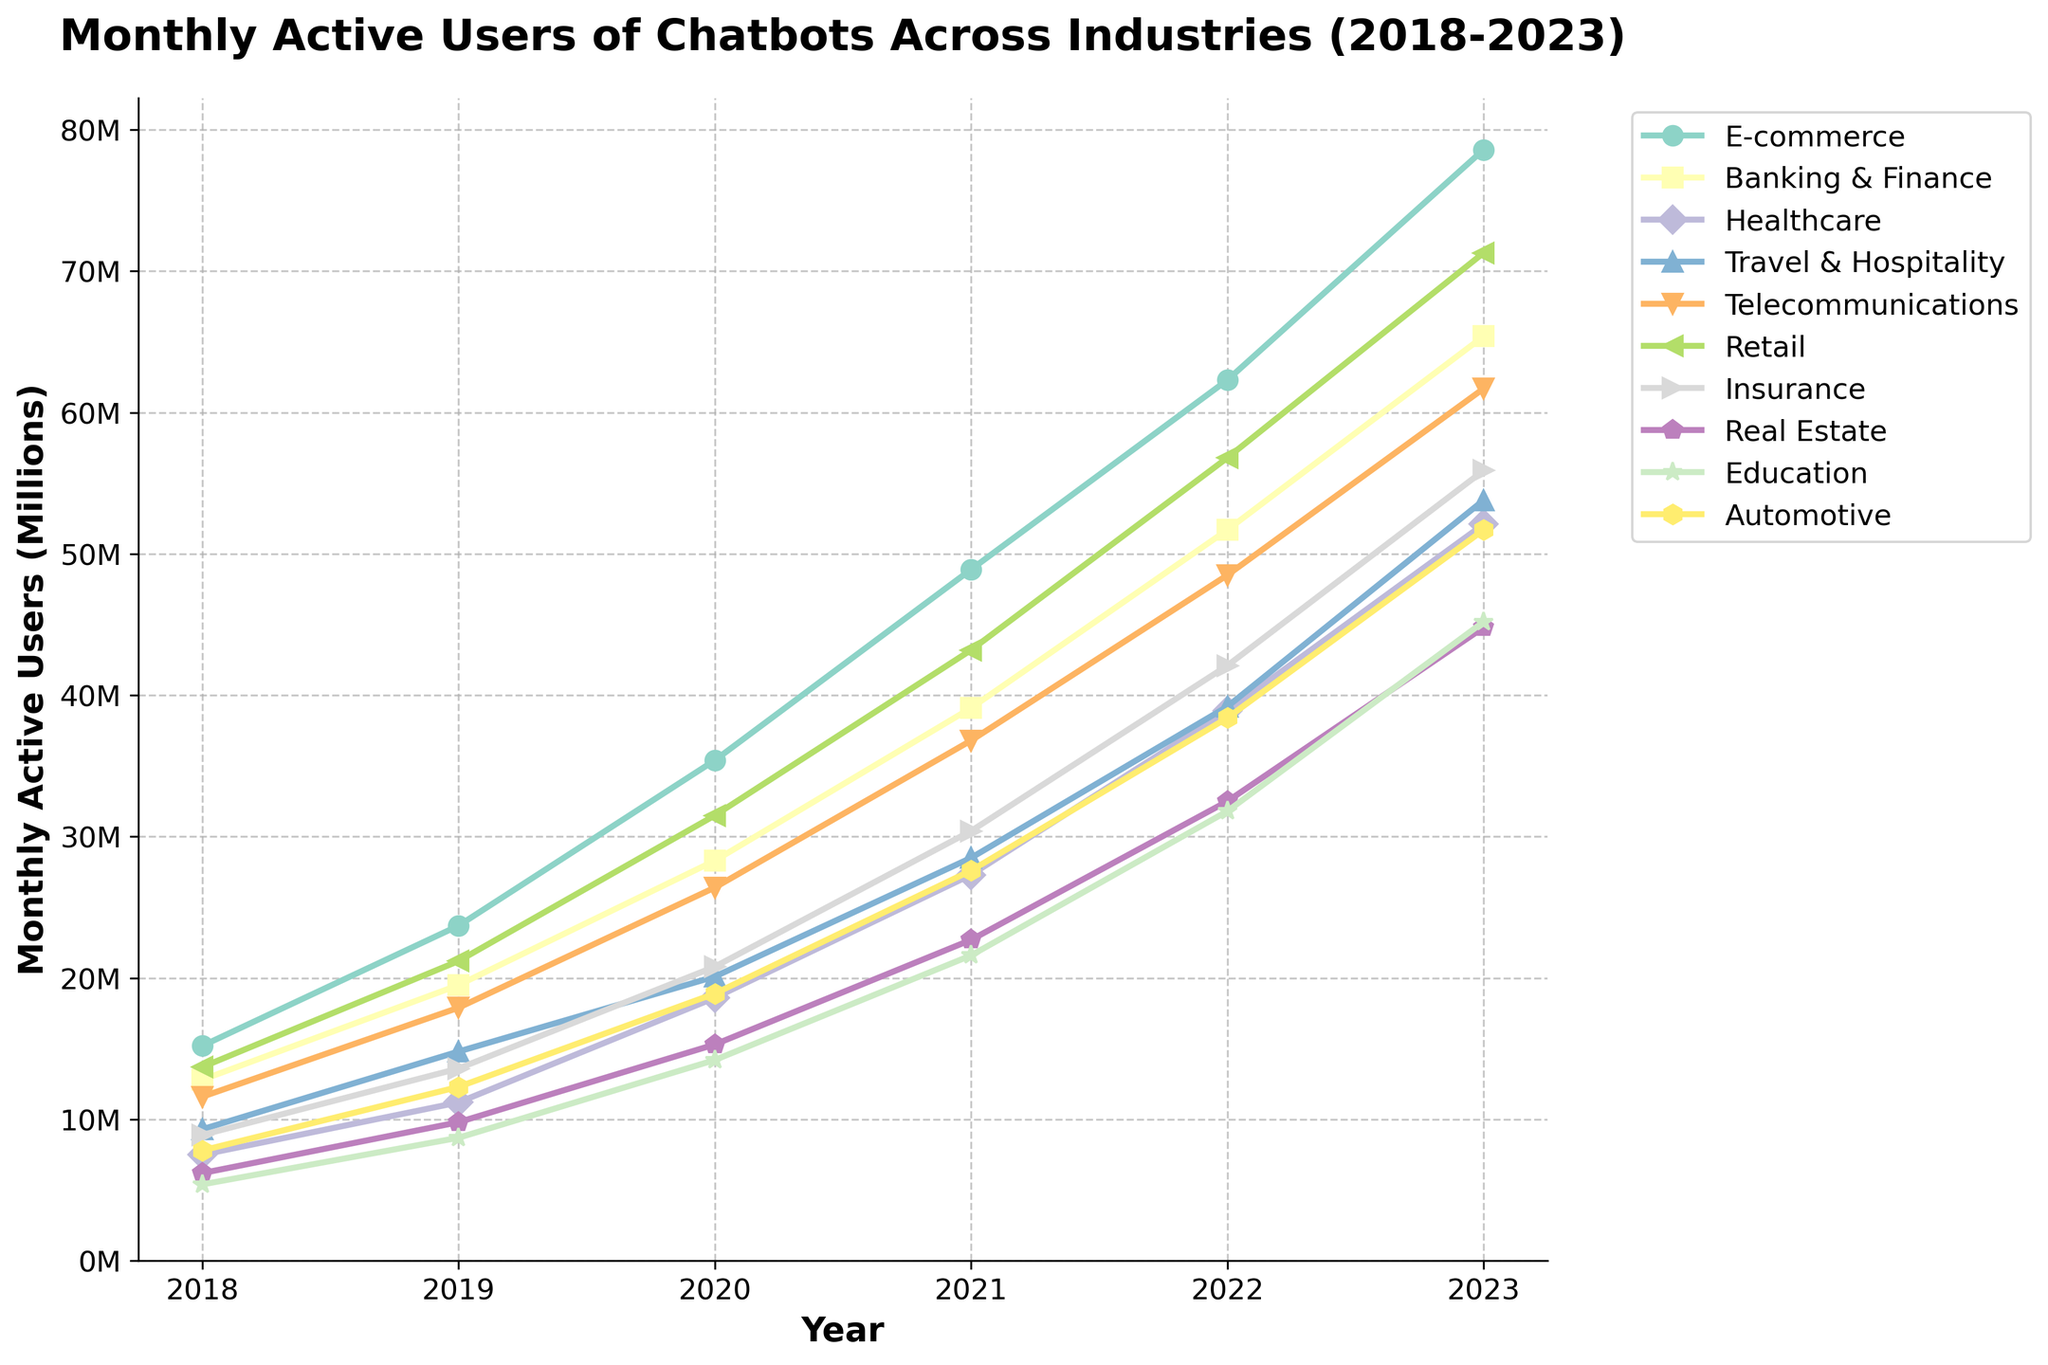what industry has the highest number of monthly active users in 2023? The figure shows multiple industries with their corresponding monthly active users for each year. In 2023, the line for E-commerce reaches the highest point compared to all other industries around 78.6 million users.
Answer: E-commerce Which industry saw the greatest increase in monthly active users between 2018 and 2023? To determine this, find the difference in monthly active users for each industry between 2018 and 2023 and identify the largest difference. E-commerce increased from 15.2 million in 2018 to 78.6 million in 2023, which is a difference of 63.4 million, the highest among all industries.
Answer: E-commerce How did the Banking & Finance sector's monthly active users in 2019 compare to 2020? Locate the monthly active user values for Banking & Finance in 2019 and 2020 in the figure. In 2019, the value is 19.5 million and in 2020, it is 28.3 million. Subtracting the 2019 value from the 2020 value gives 28.3 - 19.5 = 8.8 million. Thus, Banking & Finance sector's monthly active users increased by 8.8 million from 2019 to 2020.
Answer: Increased by 8.8 million Which two industries have the closest number of monthly active users in 2023? Compare the monthly active user values of all industries in 2023. The Automotive and Healthcare sectors both have values very close to 51.7 and 52.1 million respectively, with a difference of only 0.4 million.
Answer: Automotive and Healthcare In what year did monthly active users of chatbots in the Healthcare sector exceed 25 million? Examine the line representing Healthcare and find the year when it surpasses 25 million users. The value exceeds 25 million users in 2021, with a value of 27.3 million.
Answer: 2021 Which industry had the lowest number of monthly active users in 2018, and what was it? The lowest point on the chart for 2018 is the Education sector with 5.4 million monthly active users.
Answer: Education How does the trend of monthly active users in the Real Estate industry from 2018 to 2023 compare visually to the trend in the Retail industry? Observe both the Real Estate and Retail trend lines. The Real Estate line shows a consistent but moderate increase, whereas the Retail line shows a steeper and more rapid increase in monthly active users. This indicates that growth in the Retail industry is much faster than in the Real Estate industry.
Answer: Retail shows a steeper increase What was the average number of monthly active users across all industries in 2022? Sum the monthly active user values for all industries in 2022 and divide by the number of industries. (62.3 + 51.7 + 38.9 + 39.2 + 48.5 + 56.8 + 42.1 + 32.5 + 31.8 + 38.4) / 10 = 44.22 million.
Answer: 44.22 million 